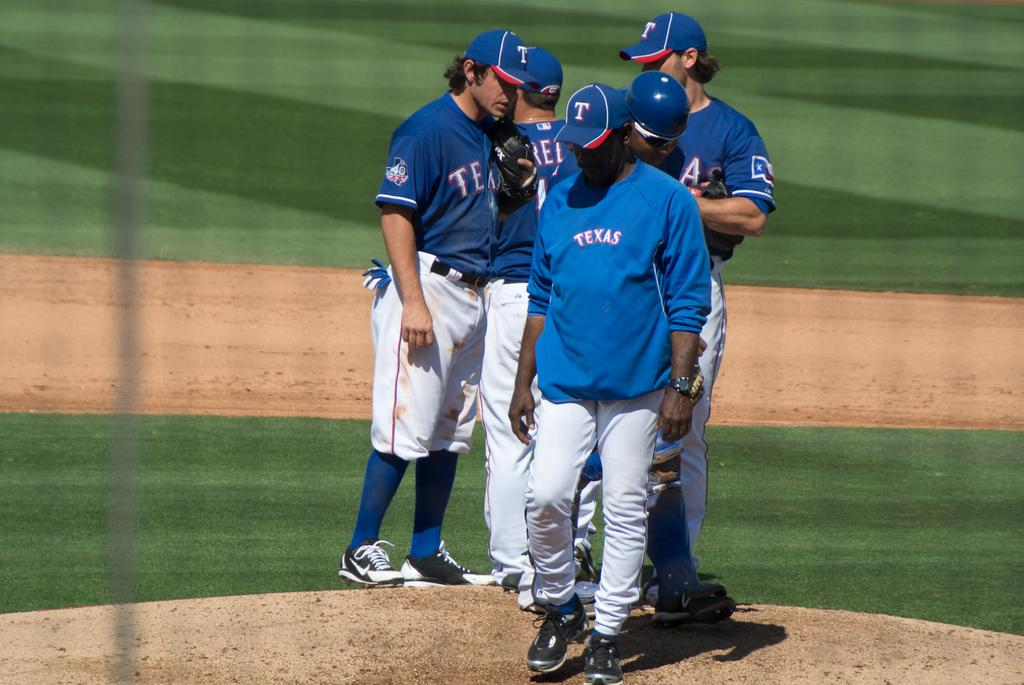<image>
Present a compact description of the photo's key features. A group of Texas Rangers baseball players are standing and talking on the field. 